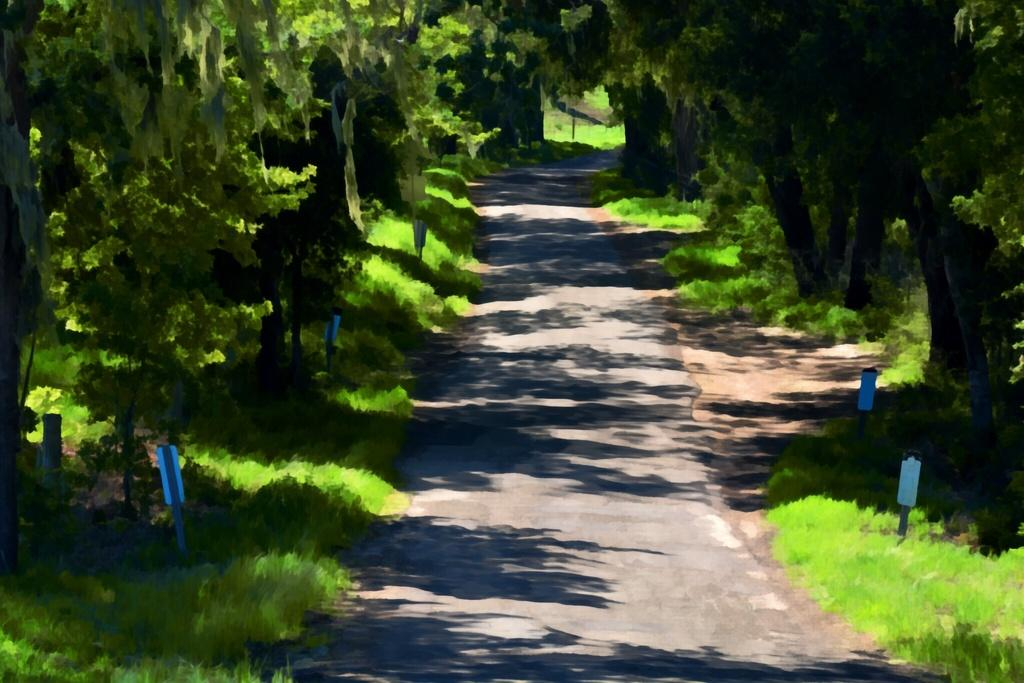What is: What is the main feature in the center of the image? There is a walkway in the center of the image. What type of vegetation can be seen on the right side of the image? There are trees and grass on the right side of the image. What type of vegetation can be seen on the left side of the image? There are trees and grass on the left side of the image. What is present on both the right and left sides of the image? There are boards present on the right side and left side of the image. Where is the dad sitting in the image? There is no dad present in the image. What type of vegetable is growing on the left side of the image? There are no vegetables present in the image; it features trees and grass. 